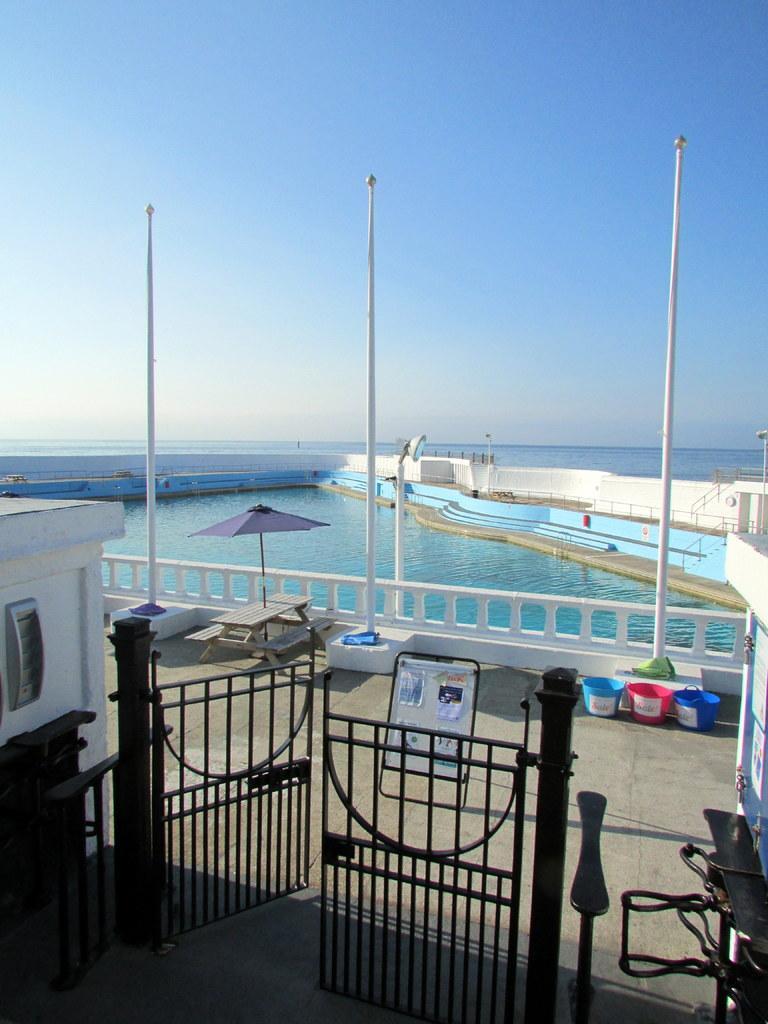In one or two sentences, can you explain what this image depicts? In this speech there is a swimming pool. Beside that I can see the status and wall. At the bottom there is a black gate. Beside that I can see the shed. Beside the umbrella I can see table, bench and clothes. On the right there are three buckets which are kept near to the poles. In the background I can see the ocean. At the top there is a sky. 